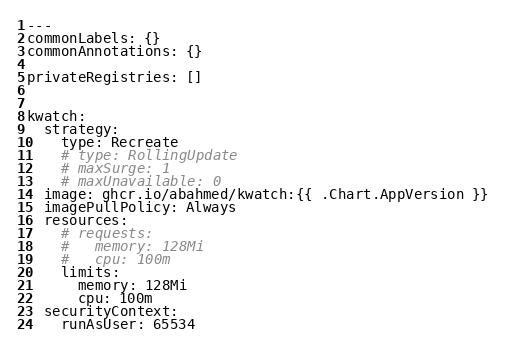Convert code to text. <code><loc_0><loc_0><loc_500><loc_500><_YAML_>---
commonLabels: {}
commonAnnotations: {}

privateRegistries: []


kwatch:
  strategy:
    type: Recreate
    # type: RollingUpdate
    # maxSurge: 1
    # maxUnavailable: 0
  image: ghcr.io/abahmed/kwatch:{{ .Chart.AppVersion }}
  imagePullPolicy: Always
  resources:
    # requests:
    #   memory: 128Mi
    #   cpu: 100m
    limits:
      memory: 128Mi
      cpu: 100m
  securityContext:
    runAsUser: 65534</code> 